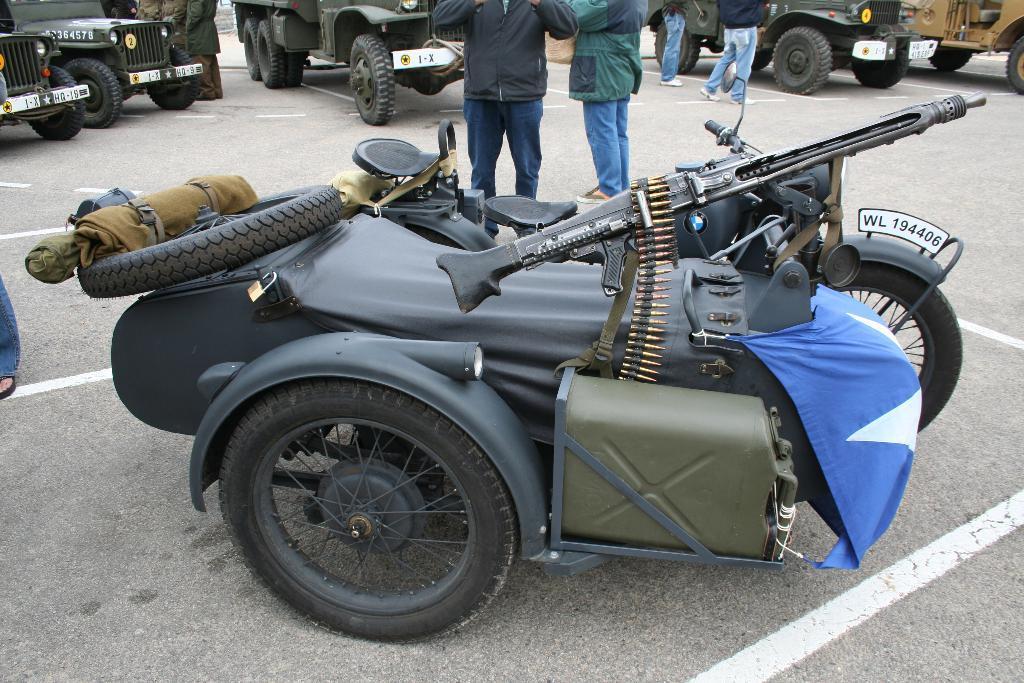Please provide a concise description of this image. In this image I can see some vehicles and some people on the road. 